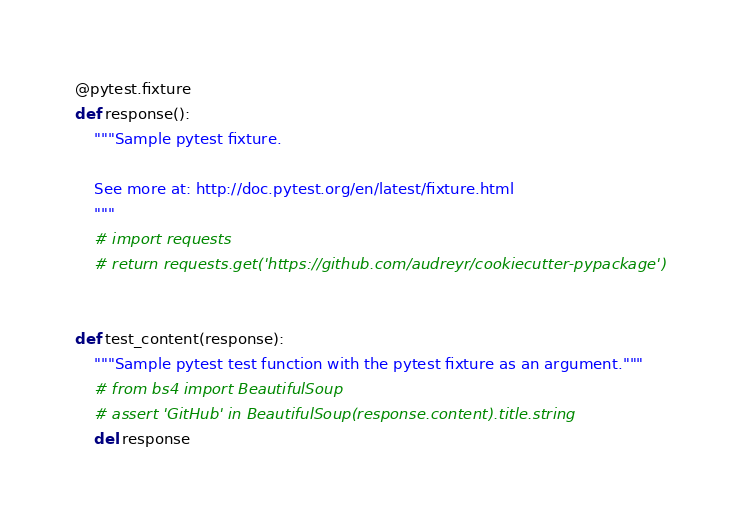<code> <loc_0><loc_0><loc_500><loc_500><_Python_>
@pytest.fixture
def response():
    """Sample pytest fixture.

    See more at: http://doc.pytest.org/en/latest/fixture.html
    """
    # import requests
    # return requests.get('https://github.com/audreyr/cookiecutter-pypackage')


def test_content(response):
    """Sample pytest test function with the pytest fixture as an argument."""
    # from bs4 import BeautifulSoup
    # assert 'GitHub' in BeautifulSoup(response.content).title.string
    del response
</code> 